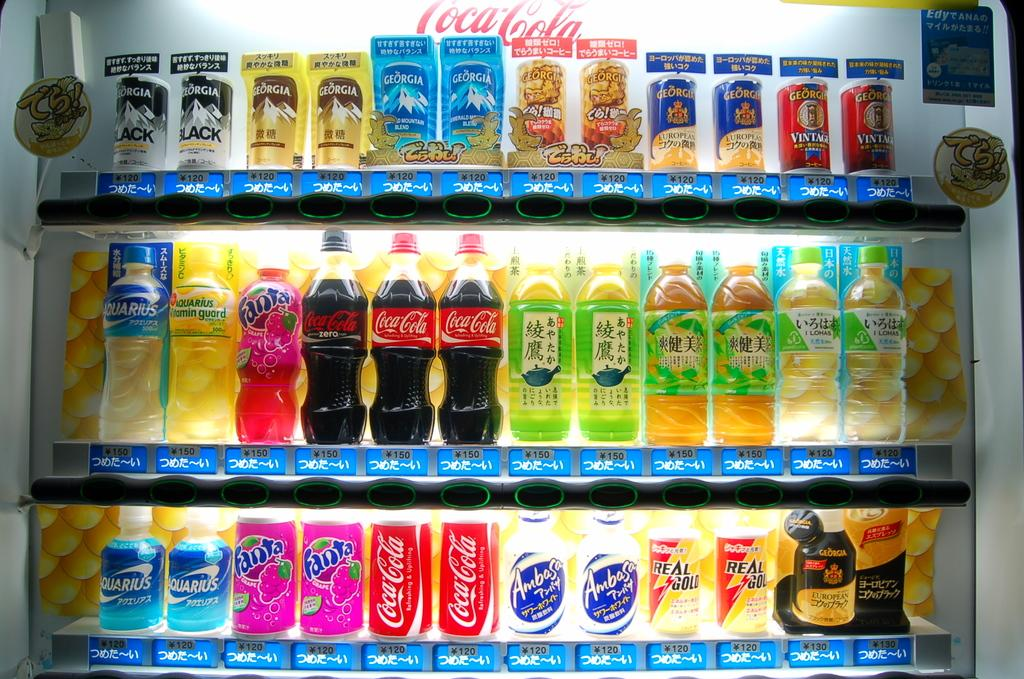<image>
Present a compact description of the photo's key features. A store shelf with different drink and Coca Cola products 